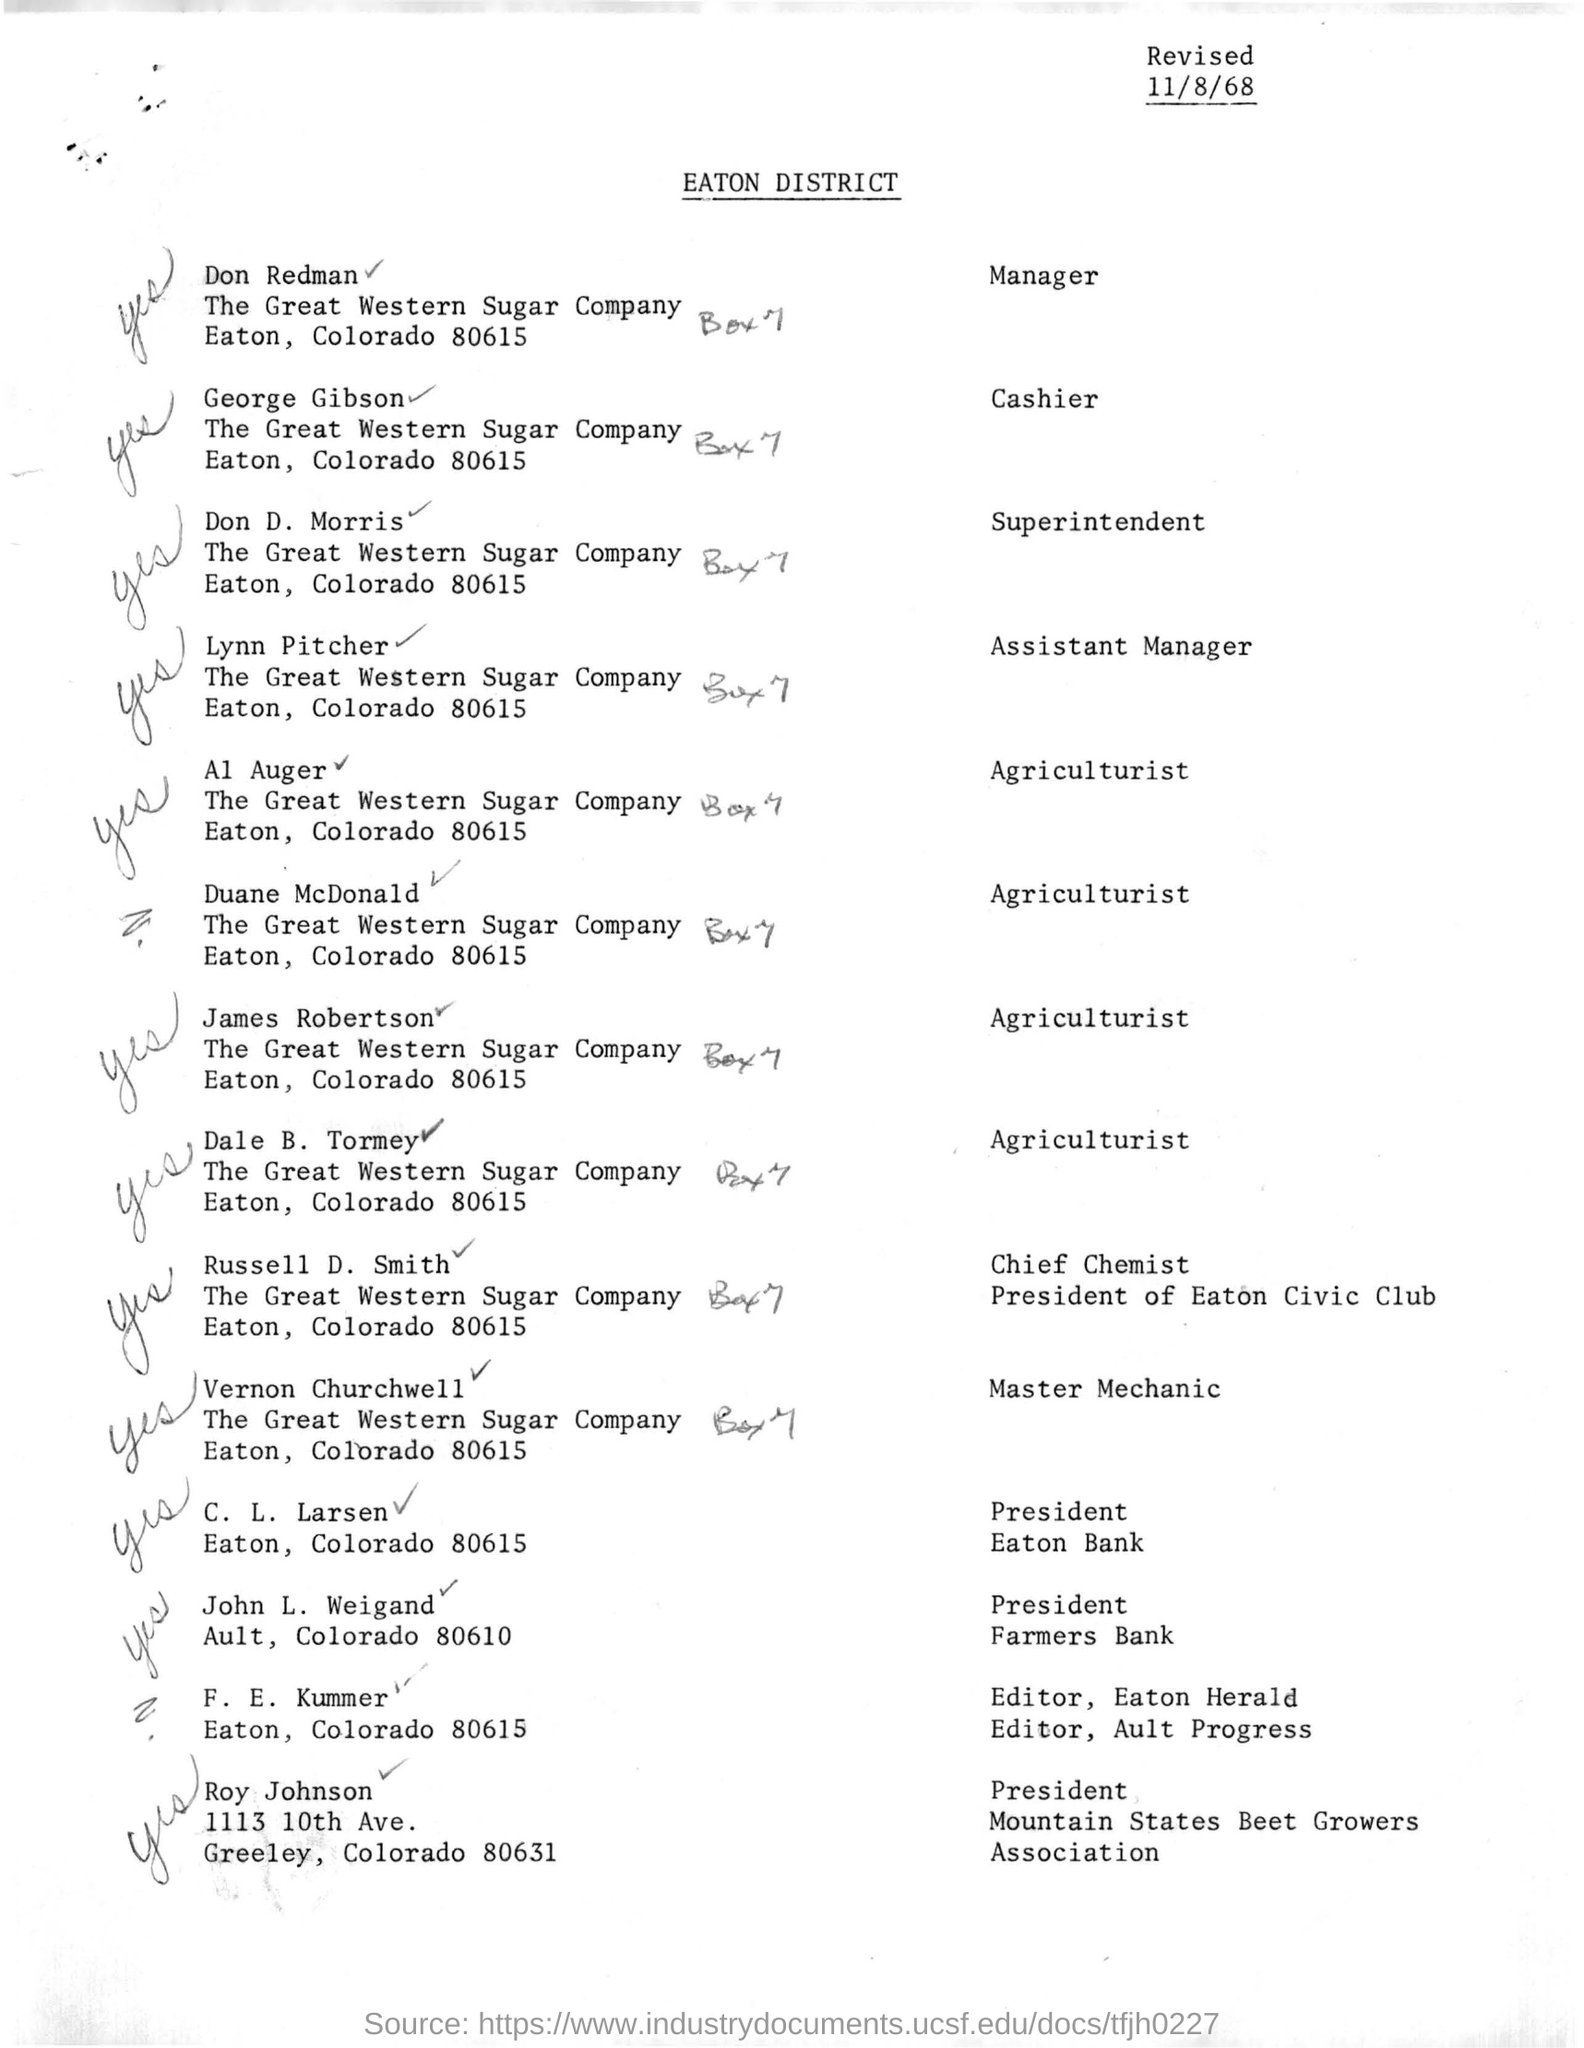Give some essential details in this illustration. The Great Western Sugar Company is located in Eaton, Colorado, specifically at 80615. George Gibson is affiliated with The Great Western Sugar Company, a company known for its cash handling services. Is the document headed "EATON DISTRICT"? 